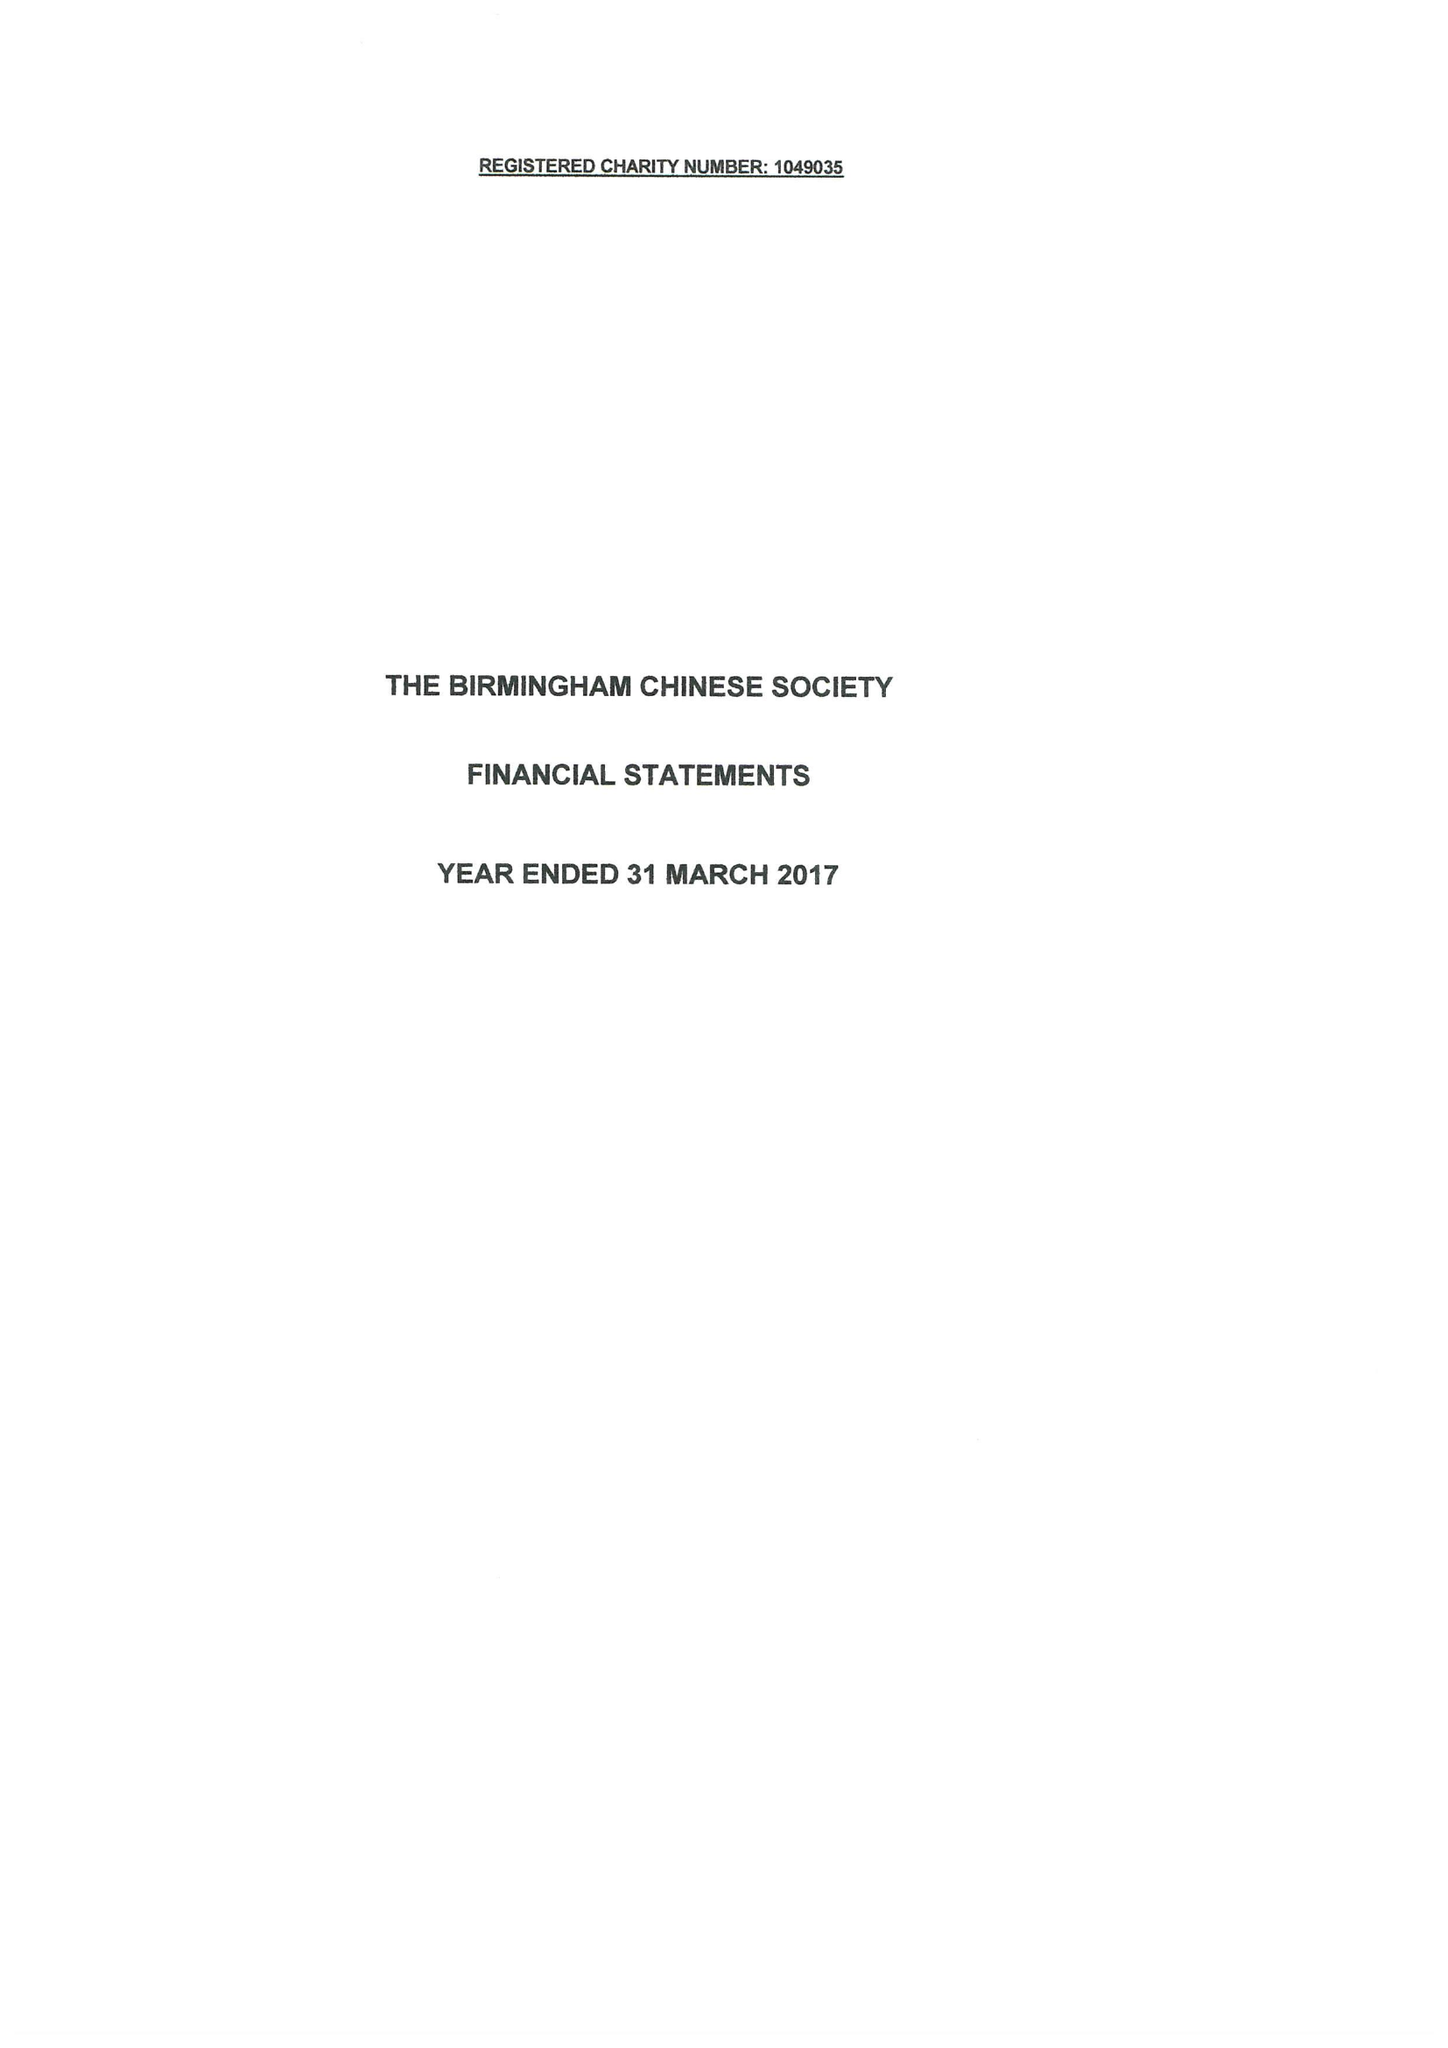What is the value for the address__street_line?
Answer the question using a single word or phrase. 11 ALLCOCK STREET 